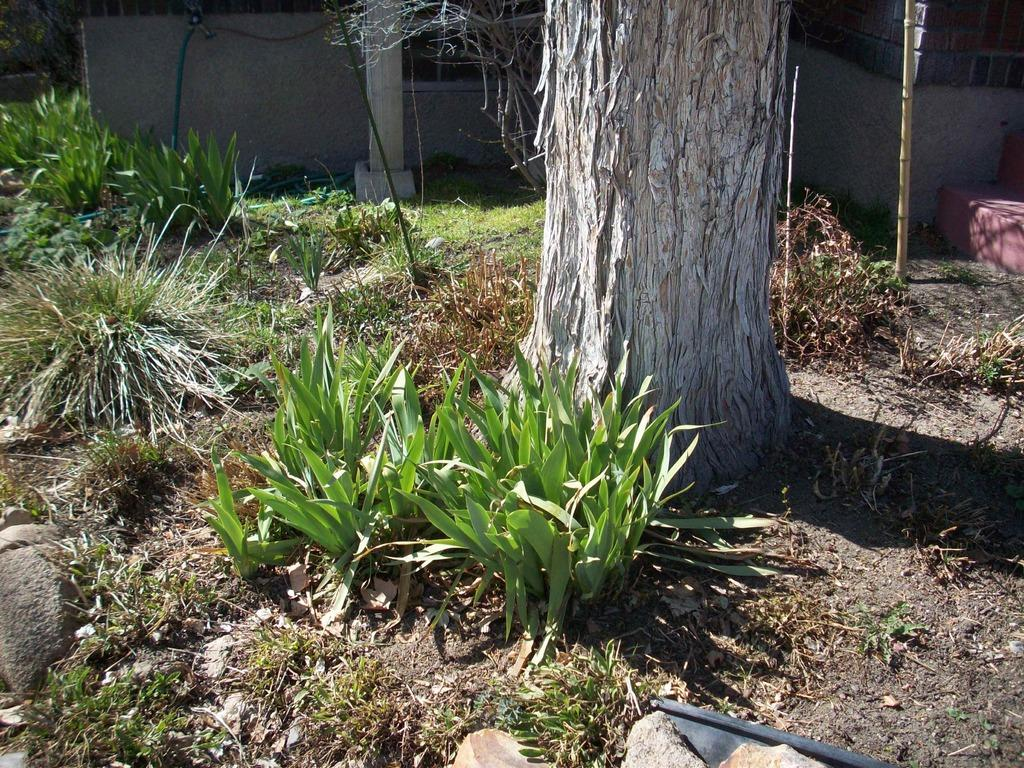What type of surface can be seen in the image? There is ground visible in the image. What type of vegetation is present in the image? There are plants in the image. What part of a tree can be seen in the image? There is a tree trunk in the image. What type of structure is visible in the background of the image? There is a house in the background of the image. What type of alarm is attached to the tree trunk in the image? There is no alarm present in the image; it only features a tree trunk, plants, ground, and a house in the background. 